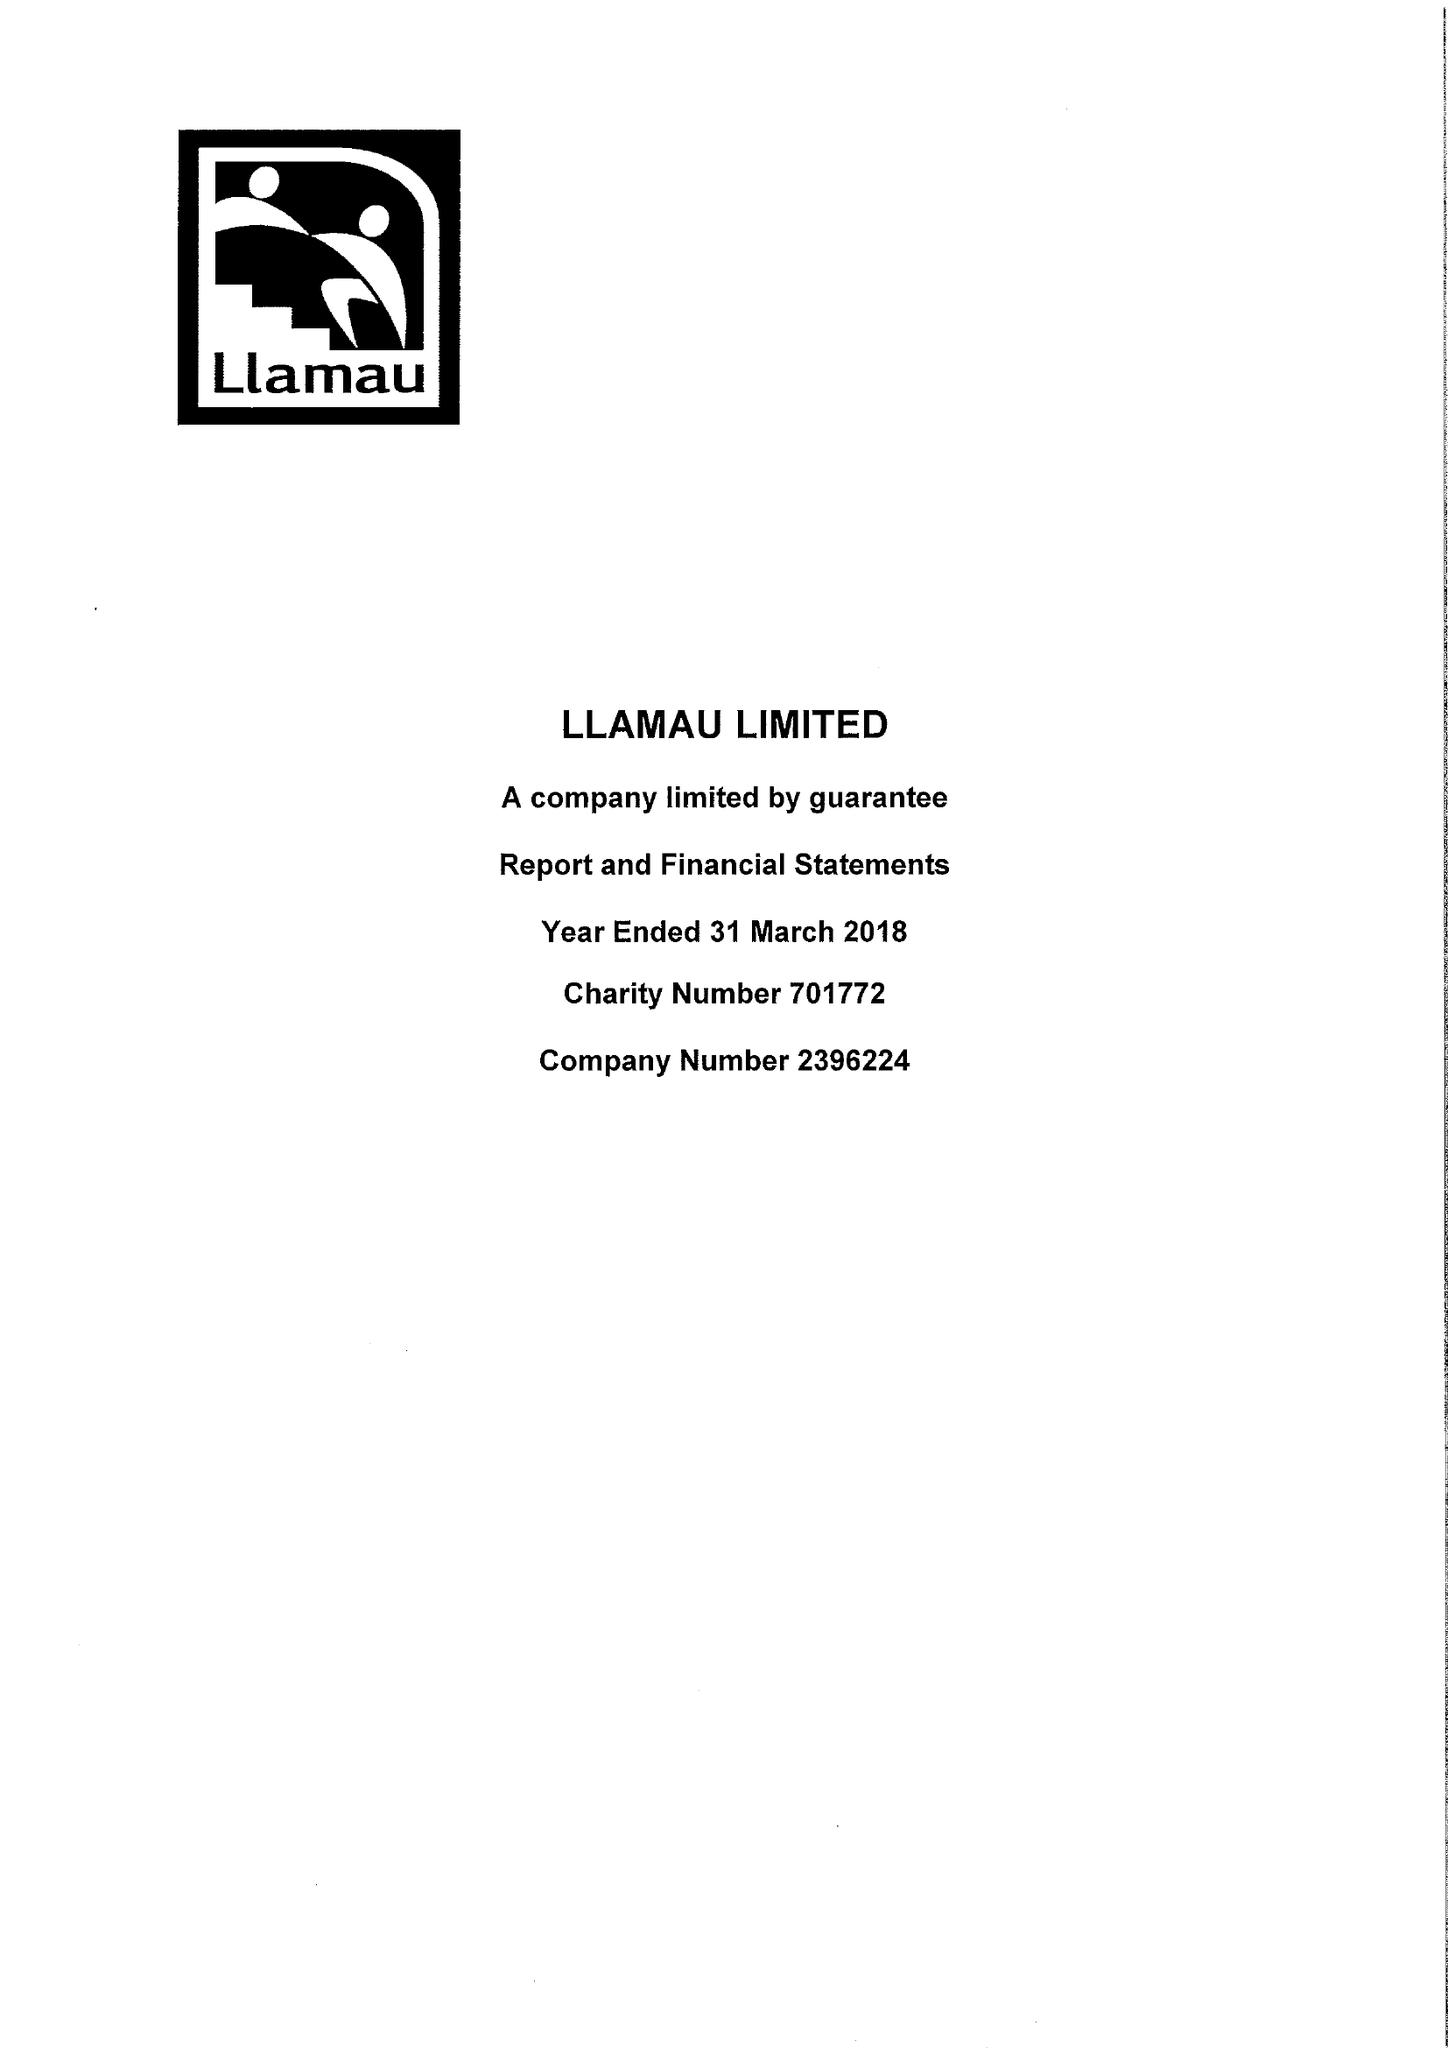What is the value for the income_annually_in_british_pounds?
Answer the question using a single word or phrase. 10657406.00 